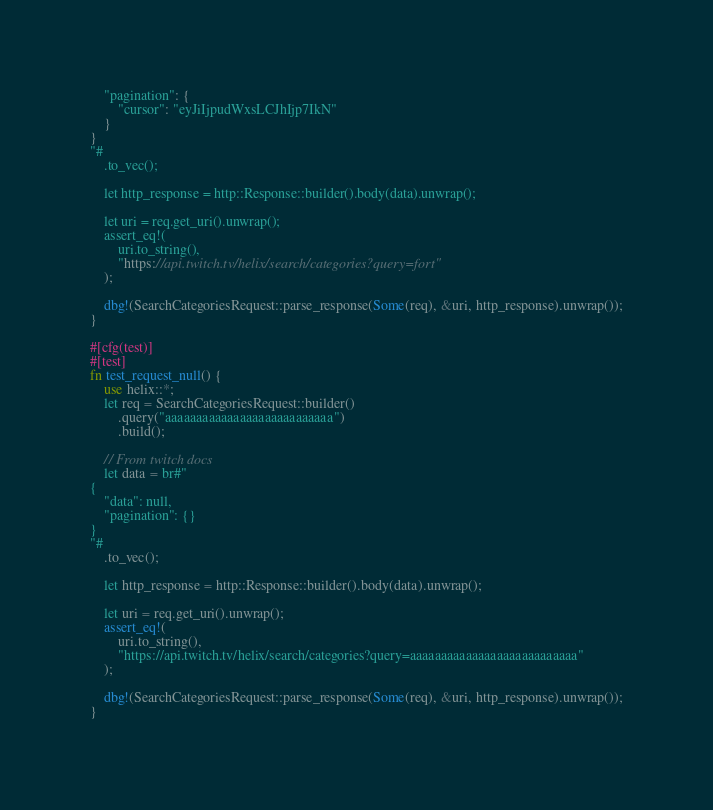<code> <loc_0><loc_0><loc_500><loc_500><_Rust_>    "pagination": {
        "cursor": "eyJiIjpudWxsLCJhIjp7IkN"
    }
}
"#
    .to_vec();

    let http_response = http::Response::builder().body(data).unwrap();

    let uri = req.get_uri().unwrap();
    assert_eq!(
        uri.to_string(),
        "https://api.twitch.tv/helix/search/categories?query=fort"
    );

    dbg!(SearchCategoriesRequest::parse_response(Some(req), &uri, http_response).unwrap());
}

#[cfg(test)]
#[test]
fn test_request_null() {
    use helix::*;
    let req = SearchCategoriesRequest::builder()
        .query("aaaaaaaaaaaaaaaaaaaaaaaaaaa")
        .build();

    // From twitch docs
    let data = br#"
{
    "data": null,
    "pagination": {}
}
"#
    .to_vec();

    let http_response = http::Response::builder().body(data).unwrap();

    let uri = req.get_uri().unwrap();
    assert_eq!(
        uri.to_string(),
        "https://api.twitch.tv/helix/search/categories?query=aaaaaaaaaaaaaaaaaaaaaaaaaaa"
    );

    dbg!(SearchCategoriesRequest::parse_response(Some(req), &uri, http_response).unwrap());
}
</code> 